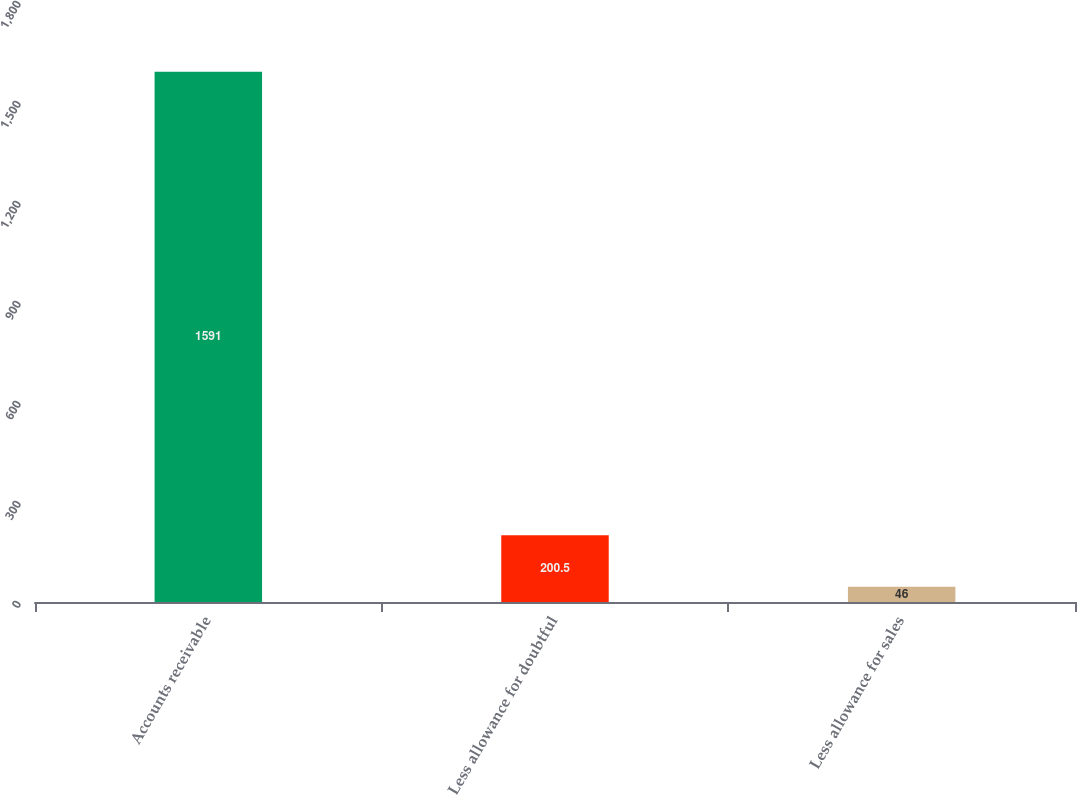Convert chart. <chart><loc_0><loc_0><loc_500><loc_500><bar_chart><fcel>Accounts receivable<fcel>Less allowance for doubtful<fcel>Less allowance for sales<nl><fcel>1591<fcel>200.5<fcel>46<nl></chart> 